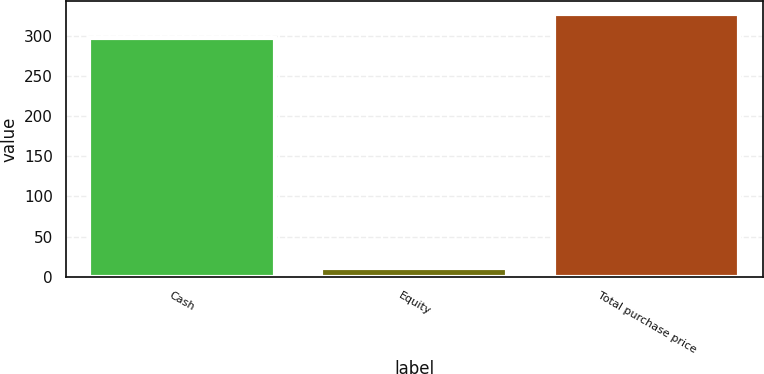<chart> <loc_0><loc_0><loc_500><loc_500><bar_chart><fcel>Cash<fcel>Equity<fcel>Total purchase price<nl><fcel>297<fcel>11<fcel>326.7<nl></chart> 